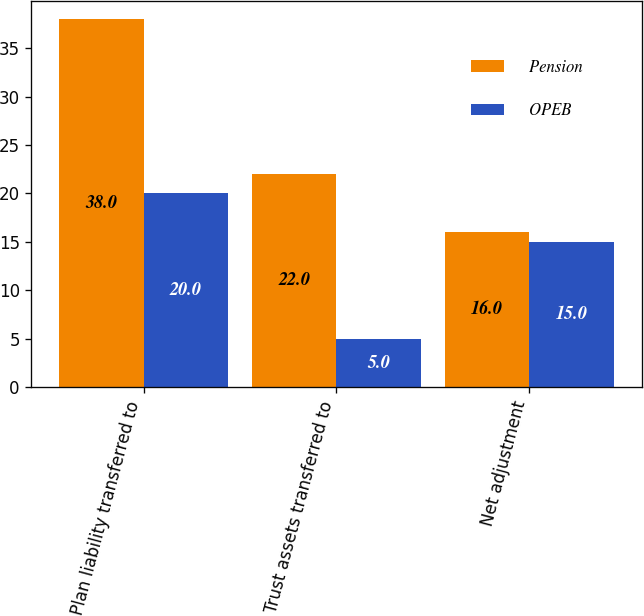<chart> <loc_0><loc_0><loc_500><loc_500><stacked_bar_chart><ecel><fcel>Plan liability transferred to<fcel>Trust assets transferred to<fcel>Net adjustment<nl><fcel>Pension<fcel>38<fcel>22<fcel>16<nl><fcel>OPEB<fcel>20<fcel>5<fcel>15<nl></chart> 